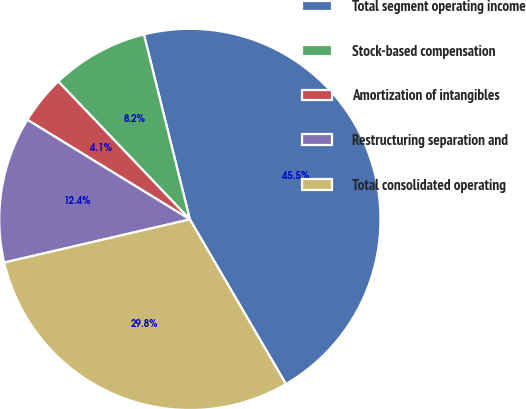<chart> <loc_0><loc_0><loc_500><loc_500><pie_chart><fcel>Total segment operating income<fcel>Stock-based compensation<fcel>Amortization of intangibles<fcel>Restructuring separation and<fcel>Total consolidated operating<nl><fcel>45.47%<fcel>8.25%<fcel>4.12%<fcel>12.39%<fcel>29.77%<nl></chart> 